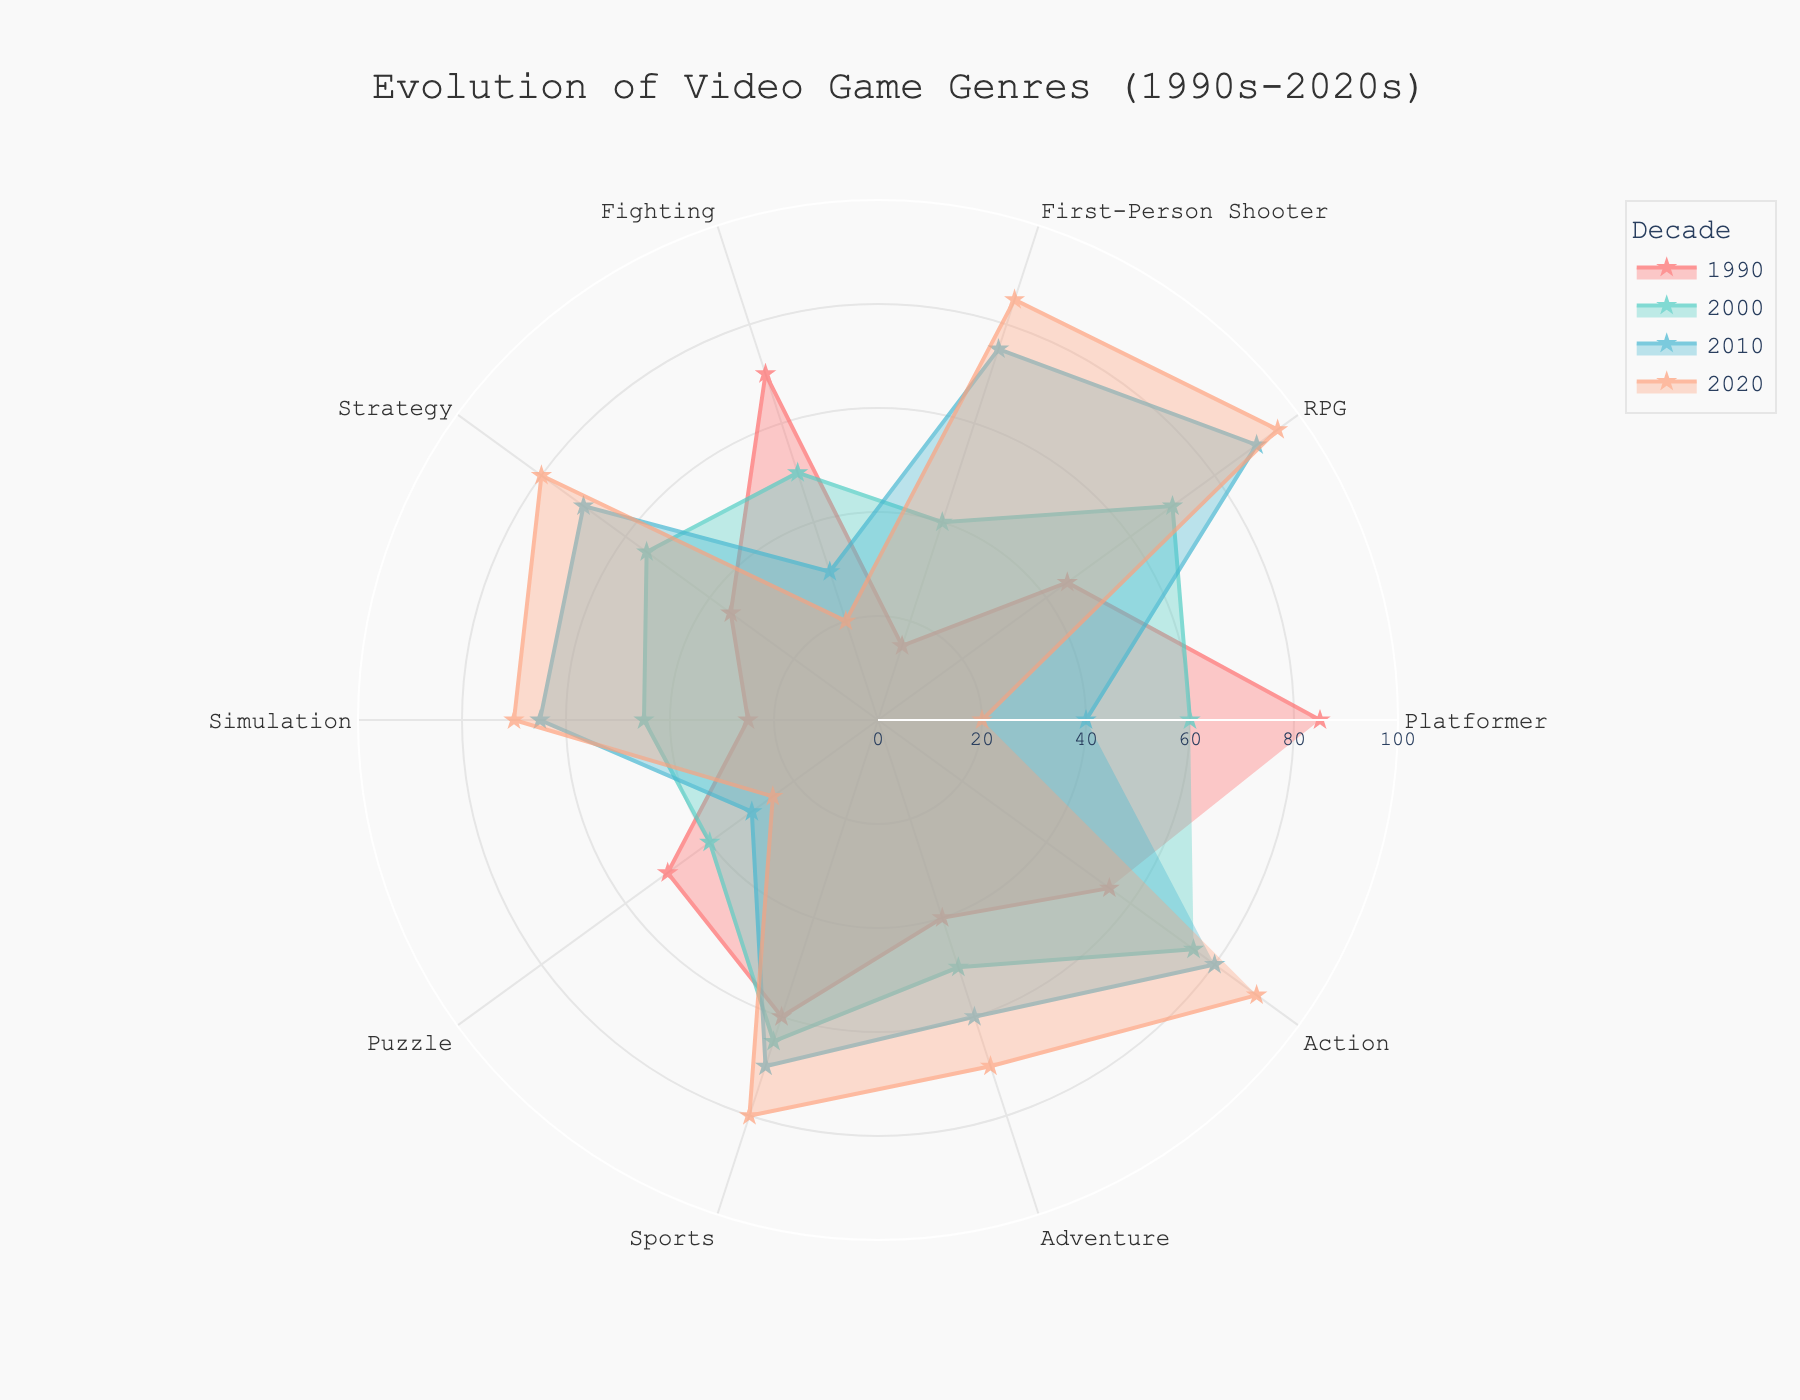What is the title of the figure? The title is normally displayed at the top of the figure, providing a high-level description of the chart's content.
Answer: Evolution of Video Game Genres (1990s-2020s) How many genres are displayed in the figure? By counting the labels on the angular axis, which represents different genres.
Answer: 10 Which genre had the highest popularity in the 1990s? By looking for the genre with the highest radial value in the 1990s decade data.
Answer: Platformer Which decade shows the highest popularity for the RPG genre? Identify the radial values for the RPG genre across all decades and find the maximum.
Answer: 2020s Does the popularity of First-Person Shooter games increase or decrease over time? Observe the trend line for First-Person Shooter across the decades from 1990 to 2020.
Answer: Increase What is the average popularity of Simulation games from 1990 to 2020? Sum the radial values for Simulation games across the decades and divide by the number of decades: (25 + 45 + 65 + 70) / 4.
Answer: 51.25 Which genres have decreased in popularity from the 1990s to the 2020s? Compare the radial values for each genre in the 1990s and the 2020s to see which values have dropped.
Answer: Platformer, Fighting, Puzzle Which decade had the widest variation in genre popularity? Inspect the spread of values (difference between the highest and lowest popularity within the decade) for each decade.
Answer: 1990s In which decade do Adventure and Action genres have similar popularity trends? Compare the radial values of Adventure and Action for each decade and find one where they are close in value.
Answer: 2010s What is the overall trend for Strategy games from 1990 to 2020? Look at the trend in radial values for Strategy games across the decades.
Answer: Increase 